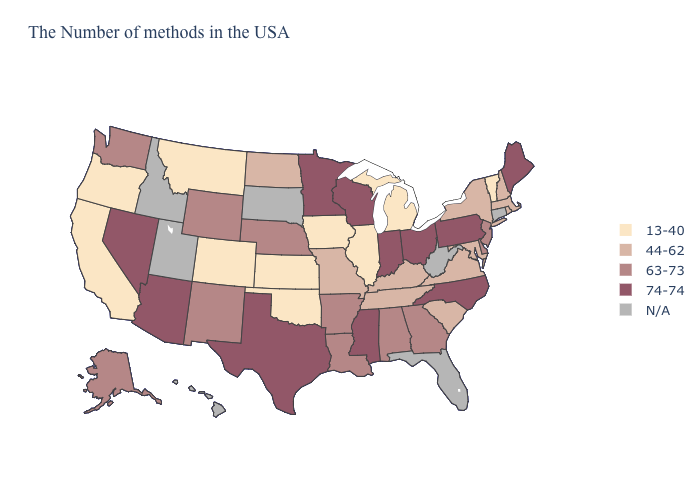What is the value of New Jersey?
Give a very brief answer. 63-73. What is the lowest value in the USA?
Answer briefly. 13-40. Among the states that border South Carolina , which have the lowest value?
Keep it brief. Georgia. Does Kentucky have the lowest value in the South?
Answer briefly. No. Name the states that have a value in the range 13-40?
Short answer required. Vermont, Michigan, Illinois, Iowa, Kansas, Oklahoma, Colorado, Montana, California, Oregon. What is the lowest value in the West?
Concise answer only. 13-40. What is the highest value in the West ?
Quick response, please. 74-74. What is the lowest value in the USA?
Answer briefly. 13-40. Name the states that have a value in the range N/A?
Answer briefly. Connecticut, West Virginia, Florida, South Dakota, Utah, Idaho, Hawaii. Does Missouri have the lowest value in the USA?
Answer briefly. No. Name the states that have a value in the range 13-40?
Be succinct. Vermont, Michigan, Illinois, Iowa, Kansas, Oklahoma, Colorado, Montana, California, Oregon. Name the states that have a value in the range 13-40?
Write a very short answer. Vermont, Michigan, Illinois, Iowa, Kansas, Oklahoma, Colorado, Montana, California, Oregon. Does Oregon have the lowest value in the USA?
Give a very brief answer. Yes. What is the value of Nevada?
Be succinct. 74-74. 